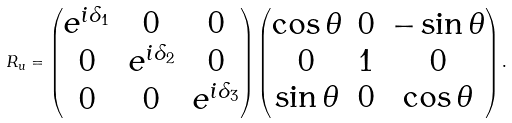<formula> <loc_0><loc_0><loc_500><loc_500>R _ { u } = \begin{pmatrix} e ^ { i \delta _ { 1 } } & 0 & 0 \\ 0 & e ^ { i \delta _ { 2 } } & 0 \\ 0 & 0 & e ^ { i \delta _ { 3 } } \end{pmatrix} \begin{pmatrix} \cos \theta & 0 & - \sin \theta \\ 0 & 1 & 0 \\ \sin \theta & 0 & \cos \theta \end{pmatrix} .</formula> 